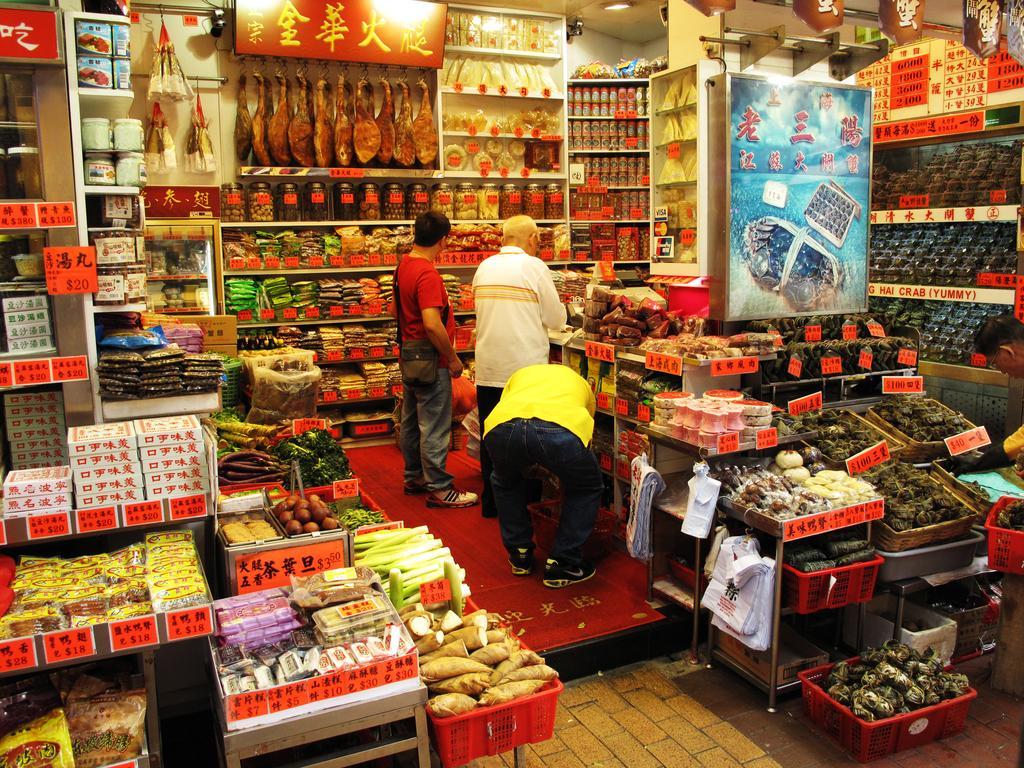Can you describe this image briefly? This picture looks like a store and I can see few items on the shelves and I can see boards with some text and few people standing and few lights to the ceiling and I can see few baskets and bottles on the shelves. 